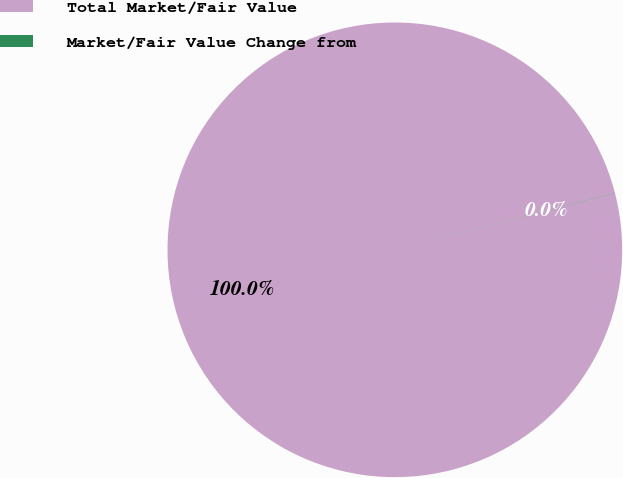Convert chart. <chart><loc_0><loc_0><loc_500><loc_500><pie_chart><fcel>Total Market/Fair Value<fcel>Market/Fair Value Change from<nl><fcel>99.98%<fcel>0.02%<nl></chart> 